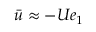Convert formula to latex. <formula><loc_0><loc_0><loc_500><loc_500>\bar { u } \approx - U e _ { 1 }</formula> 